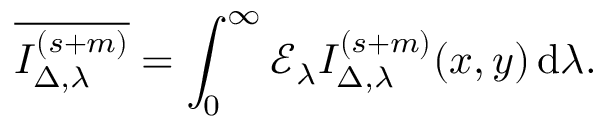Convert formula to latex. <formula><loc_0><loc_0><loc_500><loc_500>\overline { { I _ { { \Delta } , \lambda } ^ { ( s + m ) } } } = \int _ { 0 } ^ { \infty } \mathcal { E } _ { \lambda } I _ { \Delta , \lambda } ^ { ( s + m ) } ( x , y ) \, d \lambda .</formula> 